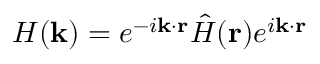Convert formula to latex. <formula><loc_0><loc_0><loc_500><loc_500>H ( k ) = e ^ { - i k \cdot r } \hat { H } ( r ) e ^ { i k \cdot r }</formula> 